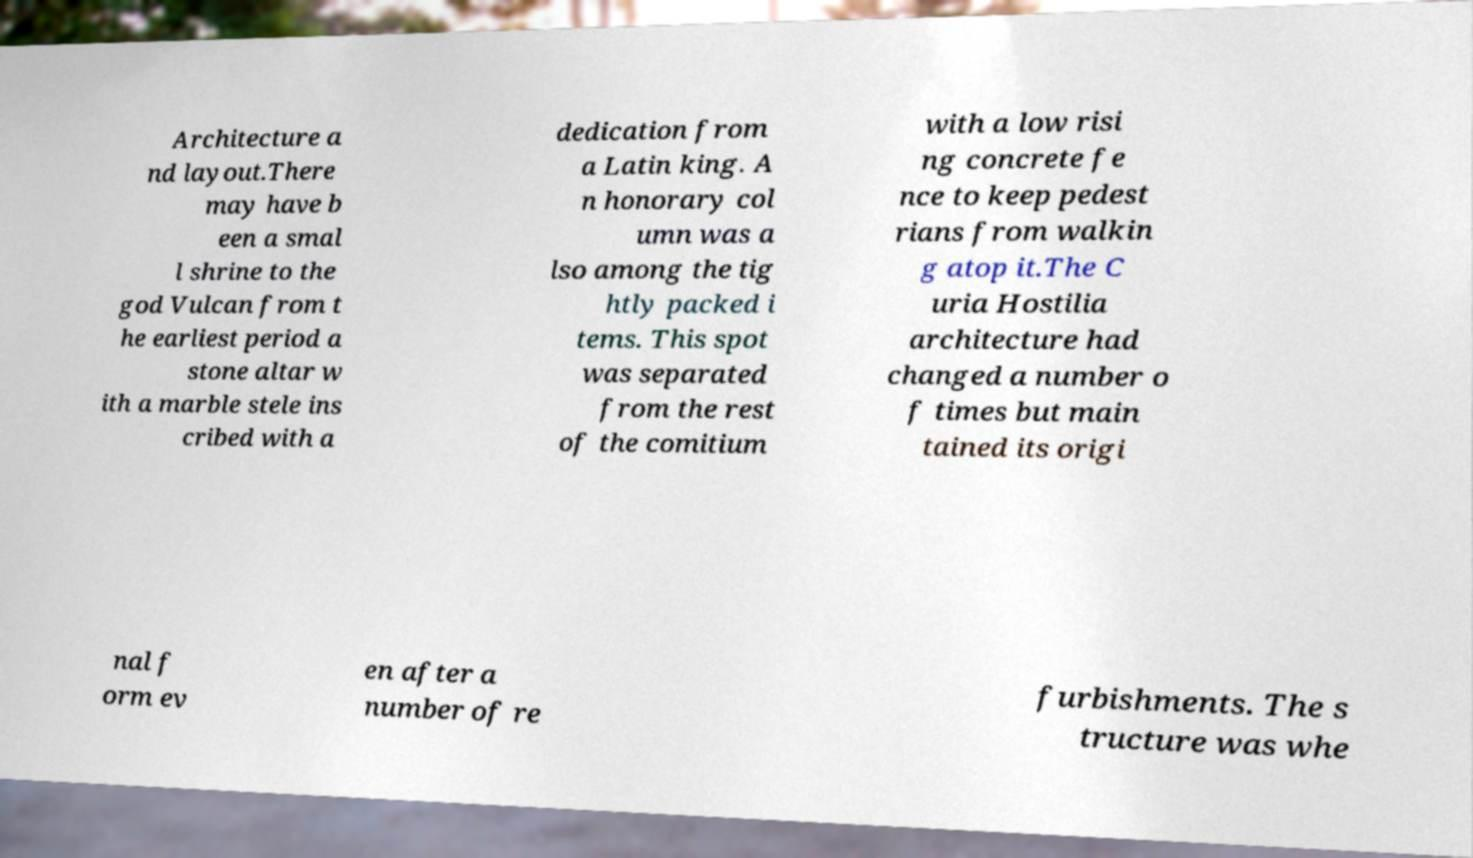Could you assist in decoding the text presented in this image and type it out clearly? Architecture a nd layout.There may have b een a smal l shrine to the god Vulcan from t he earliest period a stone altar w ith a marble stele ins cribed with a dedication from a Latin king. A n honorary col umn was a lso among the tig htly packed i tems. This spot was separated from the rest of the comitium with a low risi ng concrete fe nce to keep pedest rians from walkin g atop it.The C uria Hostilia architecture had changed a number o f times but main tained its origi nal f orm ev en after a number of re furbishments. The s tructure was whe 